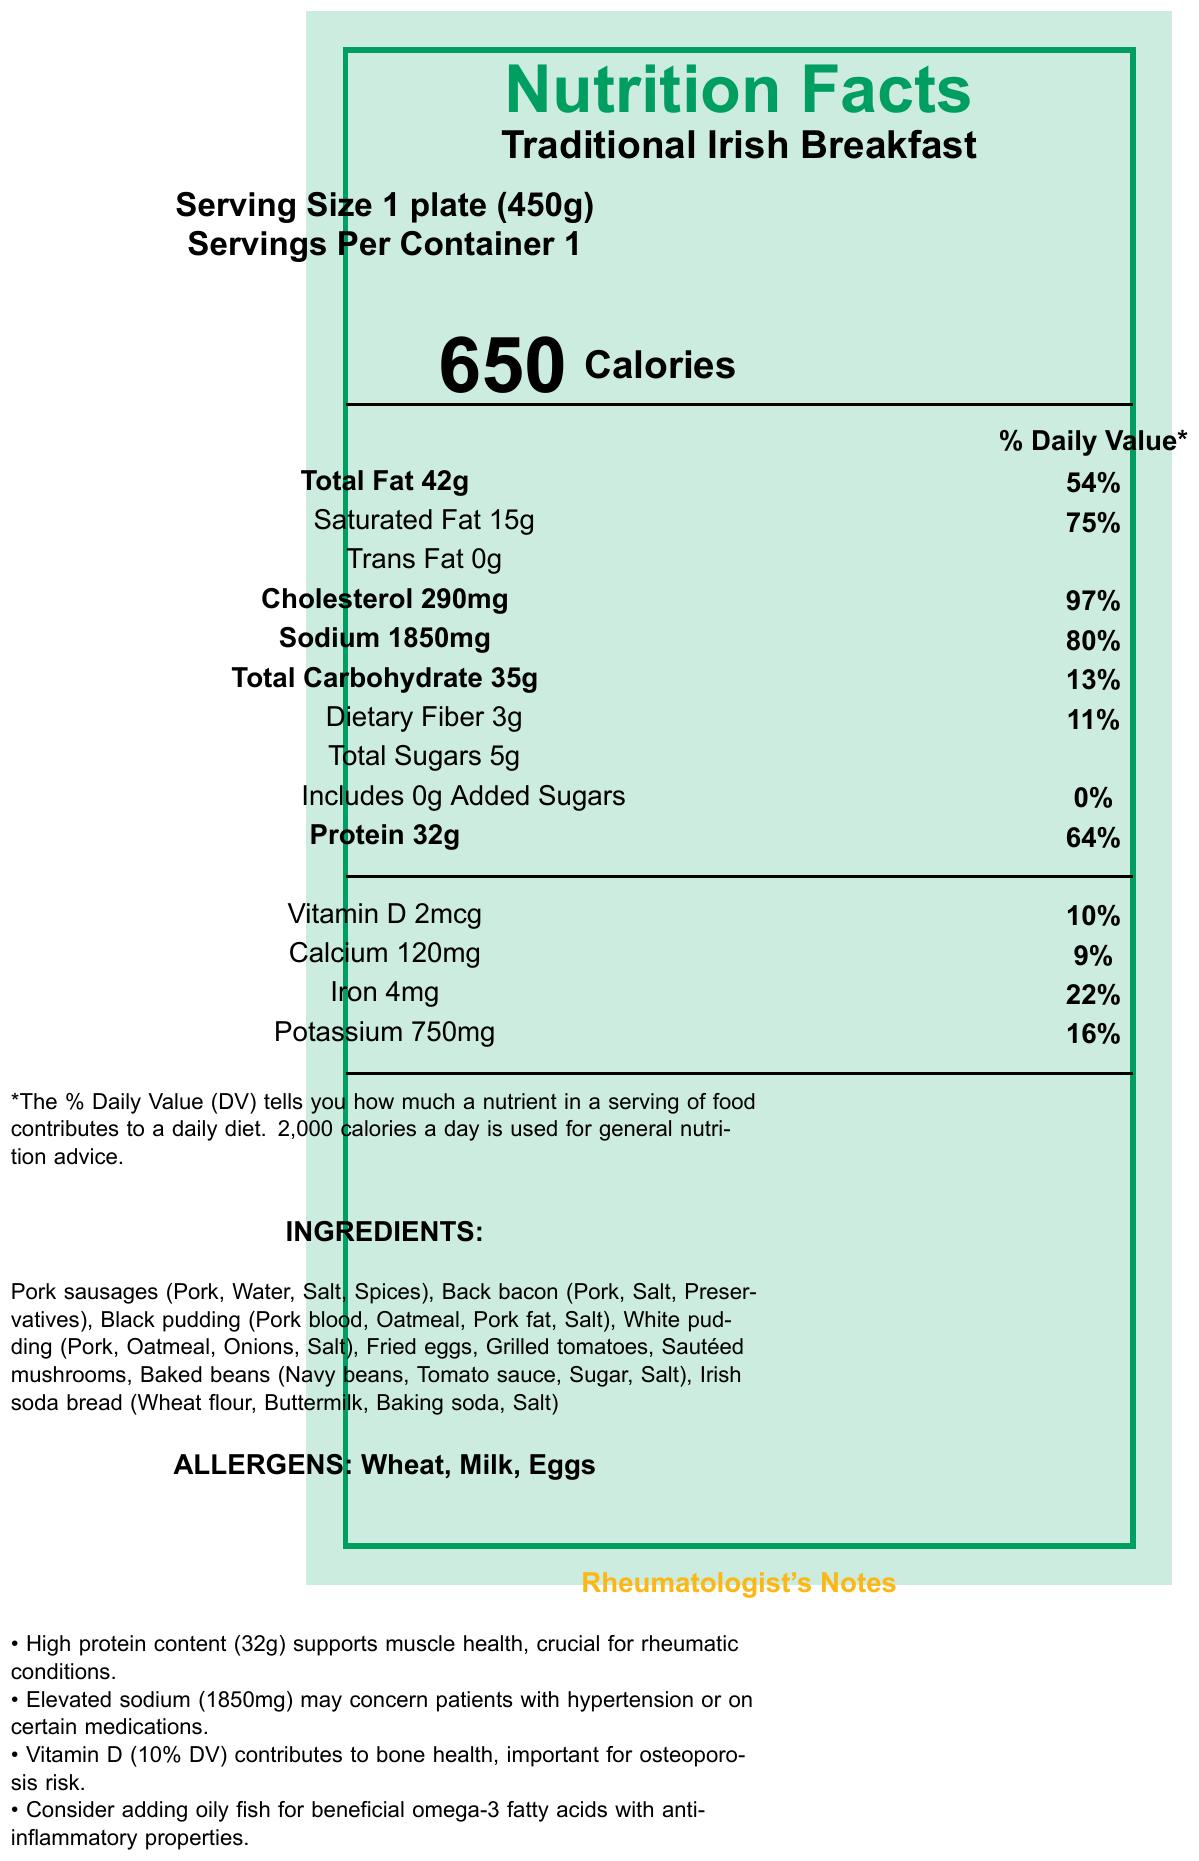what is the serving size? The serving size is indicated near the top of the document under the title "Serving Size."
Answer: 1 plate (450g) how many calories are in one serving of a traditional Irish breakfast? The calorie information is displayed prominently under the section titled "Calorie Information."
Answer: 650 calories what percentage of the daily value for sodium is provided by one serving? The percentage daily value for sodium is listed next to the sodium content in the macronutrients table.
Answer: 80% how much protein does one serving provide? Protein content is specified under the protein section and highlighted in the macronutrients table.
Answer: 32g which nutrient has the highest percentage of its daily value in one serving? By comparing the percentage daily values listed, cholesterol has the highest value at 97%.
Answer: Cholesterol, 97% what are the top three ingredients listed? The ingredients section lists them in order: Pork sausages, Back bacon, Black pudding.
Answer: Pork sausages, Back bacon, Black pudding which of the following is NOT an ingredient in the traditional Irish breakfast? A. Pork sausages B. Fried eggs C. Salmon D. Black pudding Salmon is not listed in the ingredients, whereas the other options are.
Answer: C. Salmon what is the total amount of dietary fiber in one serving? The dietary fiber amount is listed under the carbohydrate section in the macronutrient information.
Answer: 3g how much vitamin D does one serving provide in micrograms (mcg)? The amount of Vitamin D in micrograms is given in the micronutrients section.
Answer: 2 mcg true or false: this traditional Irish breakfast is a good source of Vitamin C. Vitamin C is not listed as a nutrient in the provided nutrition facts.
Answer: False based on this document, should patients with hypertension be cautious about consuming this breakfast? One serving has high sodium content (1850mg, 80% of daily value), which can be a concern for hypertension.
Answer: Yes how does the protein content of this meal support patients with rheumatic conditions? The protein (32g, 64% DV) helps maintain muscle mass, crucial for patients with rheumatic conditions.
Answer: It supports muscle health and repair. list one suggestion for improving the nutritional profile of this meal. The comment suggests adding oily fish for beneficial omega-3 fatty acids with anti-inflammatory properties.
Answer: Adding oily fish according to the document, why is vitamin D important for rheumatology patients? The document notes that vitamin D is crucial for bone health, particularly for patients at risk of osteoporosis.
Answer: It contributes to bone health. what allergens are present in this traditional Irish breakfast? The allergens are explicitly listed at the bottom of the document.
Answer: Wheat, Milk, Eggs highlight the nutritional benefits and concerns listed by the rheumatologist. The rheumatologist's notes highlight these points.
Answer: High protein supports muscle health; Elevated sodium may concern hypertensive patients; Vitamin D contributes to bone health. can the total amount of trans fat be determined from this document? The document lists "Trans Fat" under the macronutrient table with an amount of 0g.
Answer: Yes, 0g what is the main idea of this document? The document provides a breakdown of the nutritional content and specific notes for rheumatology patients.
Answer: Detailed nutrition information for a traditional Irish breakfast with emphasis on protein and sodium content, including rheumatologist comments. how many grams of total sugars are included in one serving? Total sugars are listed under the carbohydrate section in the macronutrient table.
Answer: 5g cannot be determined: what is the preparation method for the back bacon used in this breakfast? The document lists ingredients but does not specify the preparation method for the back bacon.
Answer: Not enough information 